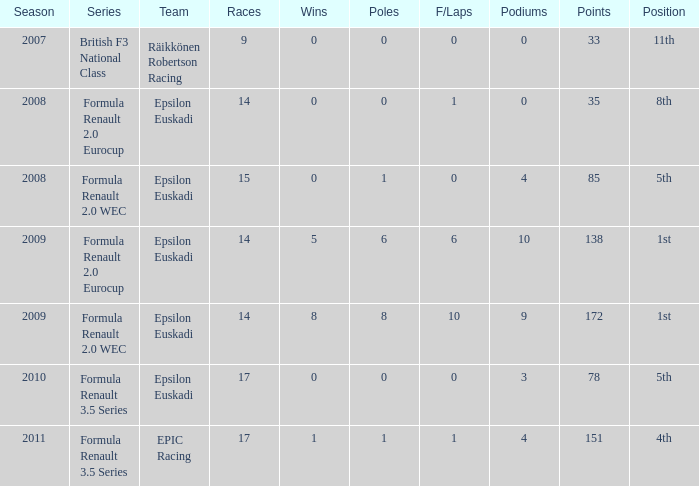How many podiums when he was in the british f3 national class series? 1.0. 